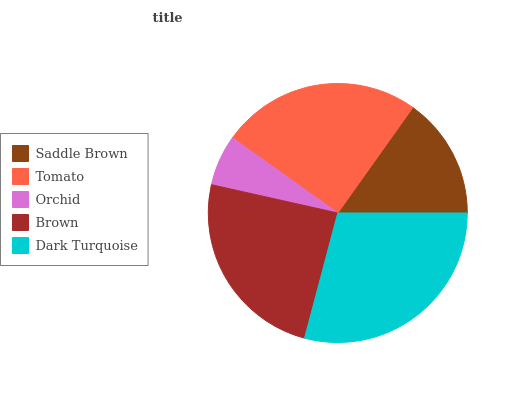Is Orchid the minimum?
Answer yes or no. Yes. Is Dark Turquoise the maximum?
Answer yes or no. Yes. Is Tomato the minimum?
Answer yes or no. No. Is Tomato the maximum?
Answer yes or no. No. Is Tomato greater than Saddle Brown?
Answer yes or no. Yes. Is Saddle Brown less than Tomato?
Answer yes or no. Yes. Is Saddle Brown greater than Tomato?
Answer yes or no. No. Is Tomato less than Saddle Brown?
Answer yes or no. No. Is Brown the high median?
Answer yes or no. Yes. Is Brown the low median?
Answer yes or no. Yes. Is Dark Turquoise the high median?
Answer yes or no. No. Is Dark Turquoise the low median?
Answer yes or no. No. 